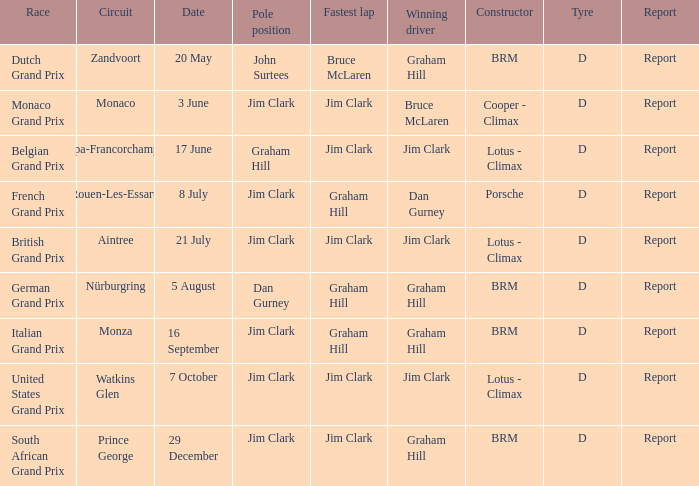What is the creator at the united states grand prix? Lotus - Climax. 